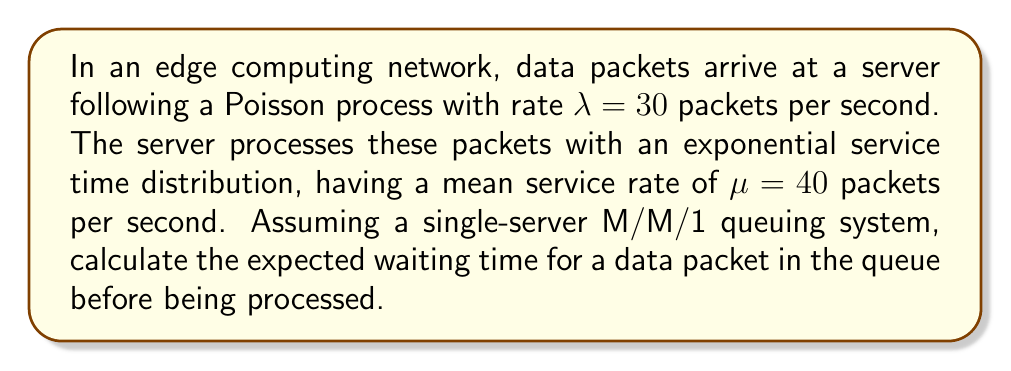Teach me how to tackle this problem. To solve this problem, we'll follow these steps:

1. Identify the system parameters:
   $\lambda = 30$ packets/second (arrival rate)
   $\mu = 40$ packets/second (service rate)

2. Calculate the system utilization $\rho$:
   $$\rho = \frac{\lambda}{\mu} = \frac{30}{40} = 0.75$$

3. Verify system stability:
   The system is stable if $\rho < 1$, which is true in this case.

4. Calculate the expected number of packets in the queue $L_q$:
   $$L_q = \frac{\rho^2}{1-\rho} = \frac{0.75^2}{1-0.75} = \frac{0.5625}{0.25} = 2.25$$

5. Apply Little's Law to find the expected waiting time $W_q$:
   $$W_q = \frac{L_q}{\lambda} = \frac{2.25}{30} = 0.075\text{ seconds}$$

Therefore, the expected waiting time for a data packet in the queue is 0.075 seconds or 75 milliseconds.
Answer: $W_q = 0.075\text{ seconds}$ 